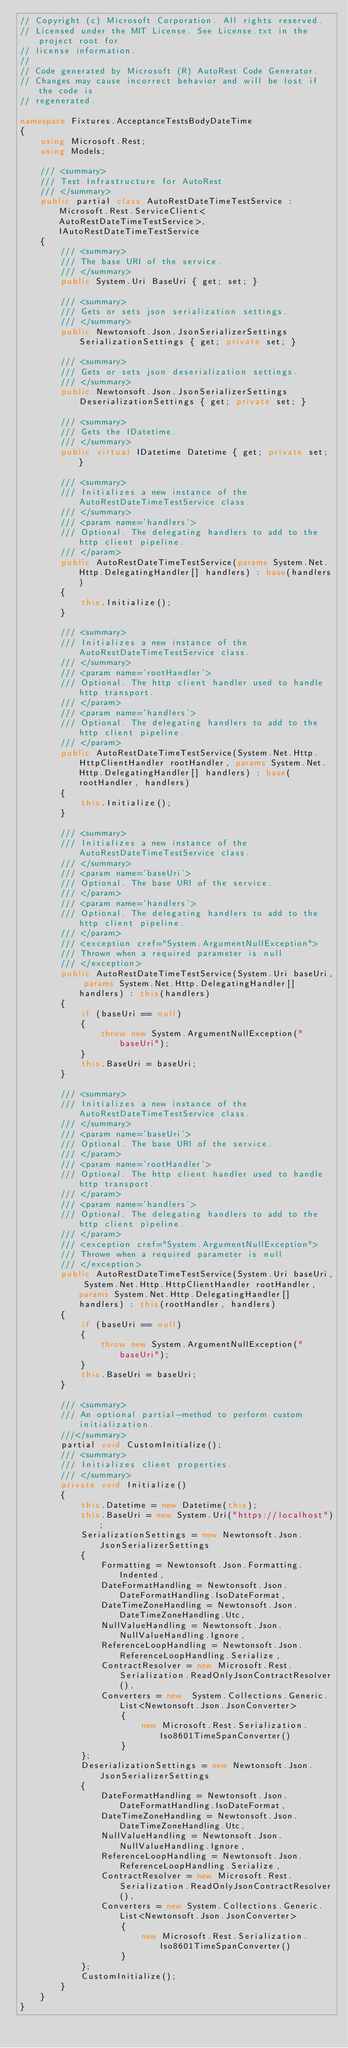Convert code to text. <code><loc_0><loc_0><loc_500><loc_500><_C#_>// Copyright (c) Microsoft Corporation. All rights reserved.
// Licensed under the MIT License. See License.txt in the project root for
// license information.
// 
// Code generated by Microsoft (R) AutoRest Code Generator.
// Changes may cause incorrect behavior and will be lost if the code is
// regenerated.

namespace Fixtures.AcceptanceTestsBodyDateTime
{
    using Microsoft.Rest;
    using Models;

    /// <summary>
    /// Test Infrastructure for AutoRest
    /// </summary>
    public partial class AutoRestDateTimeTestService : Microsoft.Rest.ServiceClient<AutoRestDateTimeTestService>, IAutoRestDateTimeTestService
    {
        /// <summary>
        /// The base URI of the service.
        /// </summary>
        public System.Uri BaseUri { get; set; }

        /// <summary>
        /// Gets or sets json serialization settings.
        /// </summary>
        public Newtonsoft.Json.JsonSerializerSettings SerializationSettings { get; private set; }

        /// <summary>
        /// Gets or sets json deserialization settings.
        /// </summary>
        public Newtonsoft.Json.JsonSerializerSettings DeserializationSettings { get; private set; }

        /// <summary>
        /// Gets the IDatetime.
        /// </summary>
        public virtual IDatetime Datetime { get; private set; }

        /// <summary>
        /// Initializes a new instance of the AutoRestDateTimeTestService class.
        /// </summary>
        /// <param name='handlers'>
        /// Optional. The delegating handlers to add to the http client pipeline.
        /// </param>
        public AutoRestDateTimeTestService(params System.Net.Http.DelegatingHandler[] handlers) : base(handlers)
        {
            this.Initialize();
        }

        /// <summary>
        /// Initializes a new instance of the AutoRestDateTimeTestService class.
        /// </summary>
        /// <param name='rootHandler'>
        /// Optional. The http client handler used to handle http transport.
        /// </param>
        /// <param name='handlers'>
        /// Optional. The delegating handlers to add to the http client pipeline.
        /// </param>
        public AutoRestDateTimeTestService(System.Net.Http.HttpClientHandler rootHandler, params System.Net.Http.DelegatingHandler[] handlers) : base(rootHandler, handlers)
        {
            this.Initialize();
        }

        /// <summary>
        /// Initializes a new instance of the AutoRestDateTimeTestService class.
        /// </summary>
        /// <param name='baseUri'>
        /// Optional. The base URI of the service.
        /// </param>
        /// <param name='handlers'>
        /// Optional. The delegating handlers to add to the http client pipeline.
        /// </param>
        /// <exception cref="System.ArgumentNullException">
        /// Thrown when a required parameter is null
        /// </exception>
        public AutoRestDateTimeTestService(System.Uri baseUri, params System.Net.Http.DelegatingHandler[] handlers) : this(handlers)
        {
            if (baseUri == null)
            {
                throw new System.ArgumentNullException("baseUri");
            }
            this.BaseUri = baseUri;
        }

        /// <summary>
        /// Initializes a new instance of the AutoRestDateTimeTestService class.
        /// </summary>
        /// <param name='baseUri'>
        /// Optional. The base URI of the service.
        /// </param>
        /// <param name='rootHandler'>
        /// Optional. The http client handler used to handle http transport.
        /// </param>
        /// <param name='handlers'>
        /// Optional. The delegating handlers to add to the http client pipeline.
        /// </param>
        /// <exception cref="System.ArgumentNullException">
        /// Thrown when a required parameter is null
        /// </exception>
        public AutoRestDateTimeTestService(System.Uri baseUri, System.Net.Http.HttpClientHandler rootHandler, params System.Net.Http.DelegatingHandler[] handlers) : this(rootHandler, handlers)
        {
            if (baseUri == null)
            {
                throw new System.ArgumentNullException("baseUri");
            }
            this.BaseUri = baseUri;
        }

        /// <summary>
        /// An optional partial-method to perform custom initialization.
        ///</summary> 
        partial void CustomInitialize();
        /// <summary>
        /// Initializes client properties.
        /// </summary>
        private void Initialize()
        {
            this.Datetime = new Datetime(this);
            this.BaseUri = new System.Uri("https://localhost");
            SerializationSettings = new Newtonsoft.Json.JsonSerializerSettings
            {
                Formatting = Newtonsoft.Json.Formatting.Indented,
                DateFormatHandling = Newtonsoft.Json.DateFormatHandling.IsoDateFormat,
                DateTimeZoneHandling = Newtonsoft.Json.DateTimeZoneHandling.Utc,
                NullValueHandling = Newtonsoft.Json.NullValueHandling.Ignore,
                ReferenceLoopHandling = Newtonsoft.Json.ReferenceLoopHandling.Serialize,
                ContractResolver = new Microsoft.Rest.Serialization.ReadOnlyJsonContractResolver(),
                Converters = new  System.Collections.Generic.List<Newtonsoft.Json.JsonConverter>
                    {
                        new Microsoft.Rest.Serialization.Iso8601TimeSpanConverter()
                    }
            };
            DeserializationSettings = new Newtonsoft.Json.JsonSerializerSettings
            {
                DateFormatHandling = Newtonsoft.Json.DateFormatHandling.IsoDateFormat,
                DateTimeZoneHandling = Newtonsoft.Json.DateTimeZoneHandling.Utc,
                NullValueHandling = Newtonsoft.Json.NullValueHandling.Ignore,
                ReferenceLoopHandling = Newtonsoft.Json.ReferenceLoopHandling.Serialize,
                ContractResolver = new Microsoft.Rest.Serialization.ReadOnlyJsonContractResolver(),
                Converters = new System.Collections.Generic.List<Newtonsoft.Json.JsonConverter>
                    {
                        new Microsoft.Rest.Serialization.Iso8601TimeSpanConverter()
                    }
            };
            CustomInitialize();
        }    
    }
}
</code> 